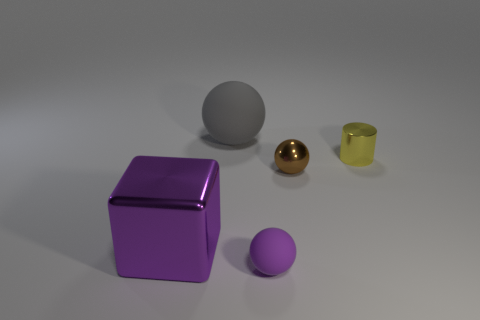There is a rubber object on the right side of the gray matte ball; is its color the same as the shiny cylinder?
Make the answer very short. No. There is a thing that is both behind the small brown shiny sphere and to the left of the small yellow metallic cylinder; what is it made of?
Make the answer very short. Rubber. Is there a gray object that has the same size as the metallic block?
Make the answer very short. Yes. How many tiny yellow metal cubes are there?
Ensure brevity in your answer.  0. There is a tiny brown metallic sphere; what number of small things are to the left of it?
Provide a short and direct response. 1. Is the large purple thing made of the same material as the gray sphere?
Your answer should be compact. No. What number of things are both in front of the small metal cylinder and behind the small yellow shiny cylinder?
Provide a succinct answer. 0. What number of other things are the same color as the large metal block?
Your response must be concise. 1. How many red objects are either big matte objects or big objects?
Provide a succinct answer. 0. What is the size of the purple cube?
Ensure brevity in your answer.  Large. 